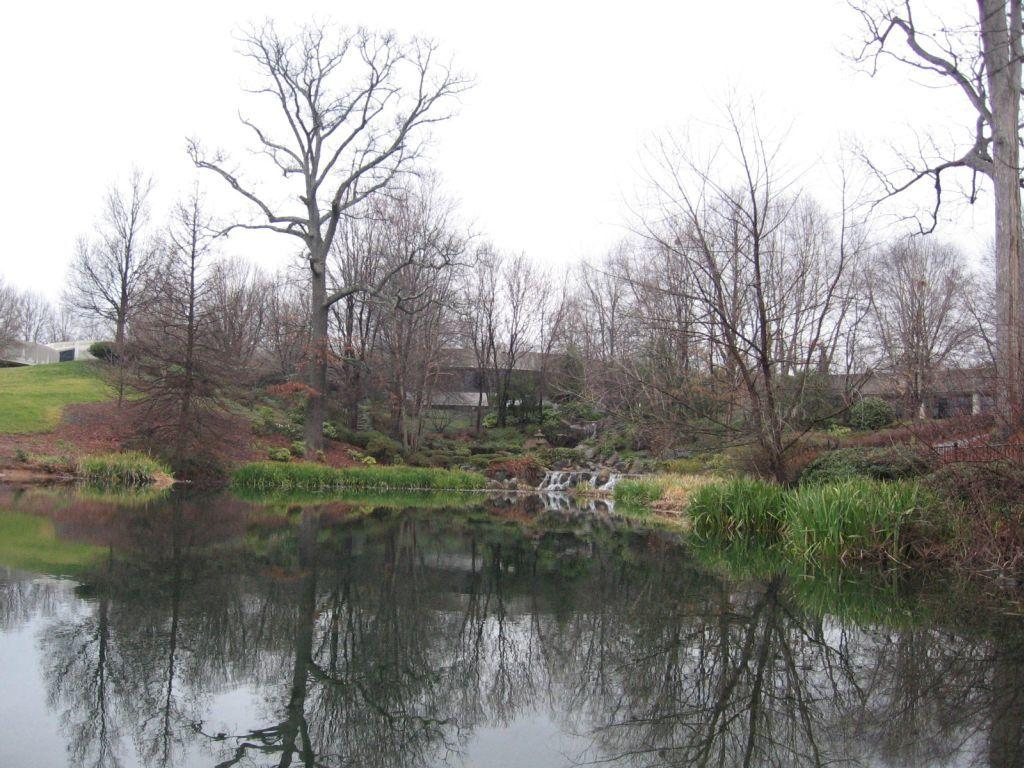What is the primary element visible in the image? There is water in the image. What type of vegetation can be seen in the image? There are trees in the image, described as green. Are there any other types of trees present in the image? Yes, there are dried trees in the image. What is visible in the sky in the image? The sky is visible in the image, described as white. How many dogs are playing with balls in the image? There are no dogs or balls present in the image. What type of porter is carrying items in the image? There is no porter present in the image. 